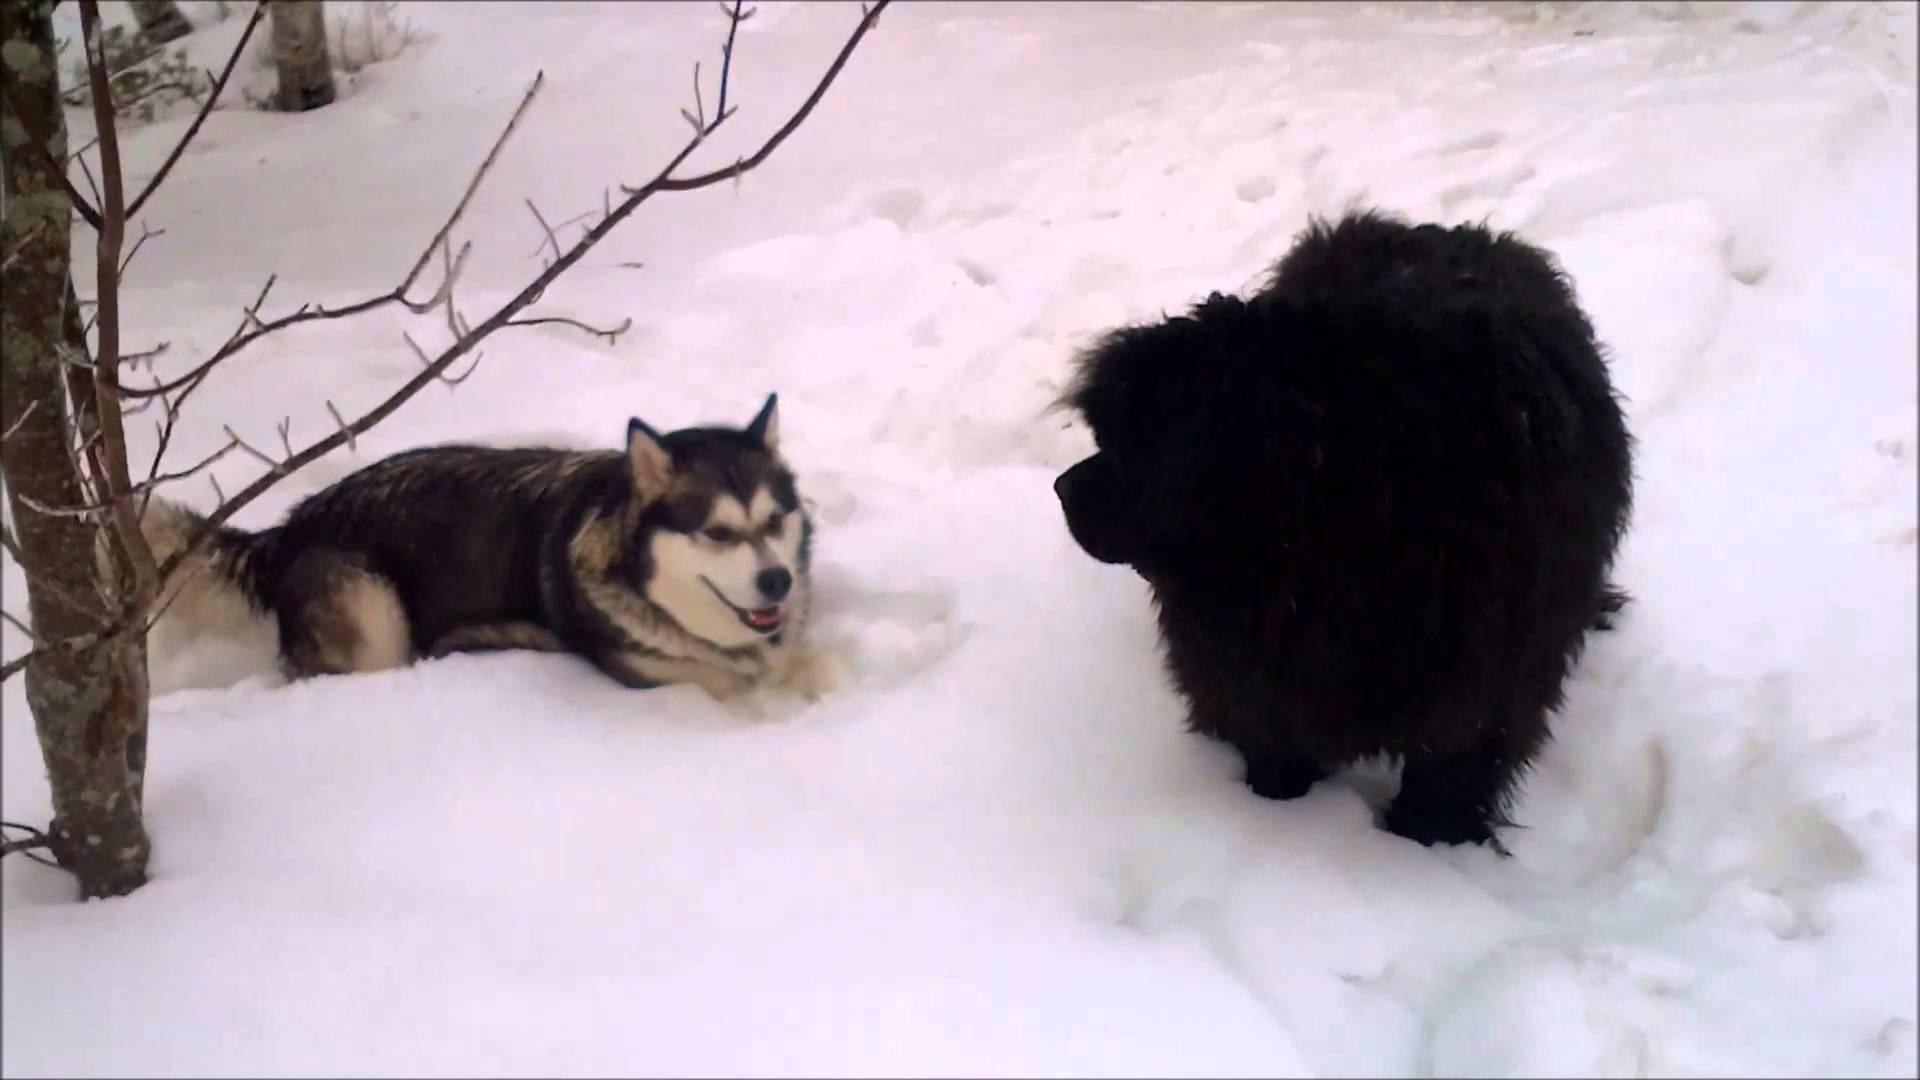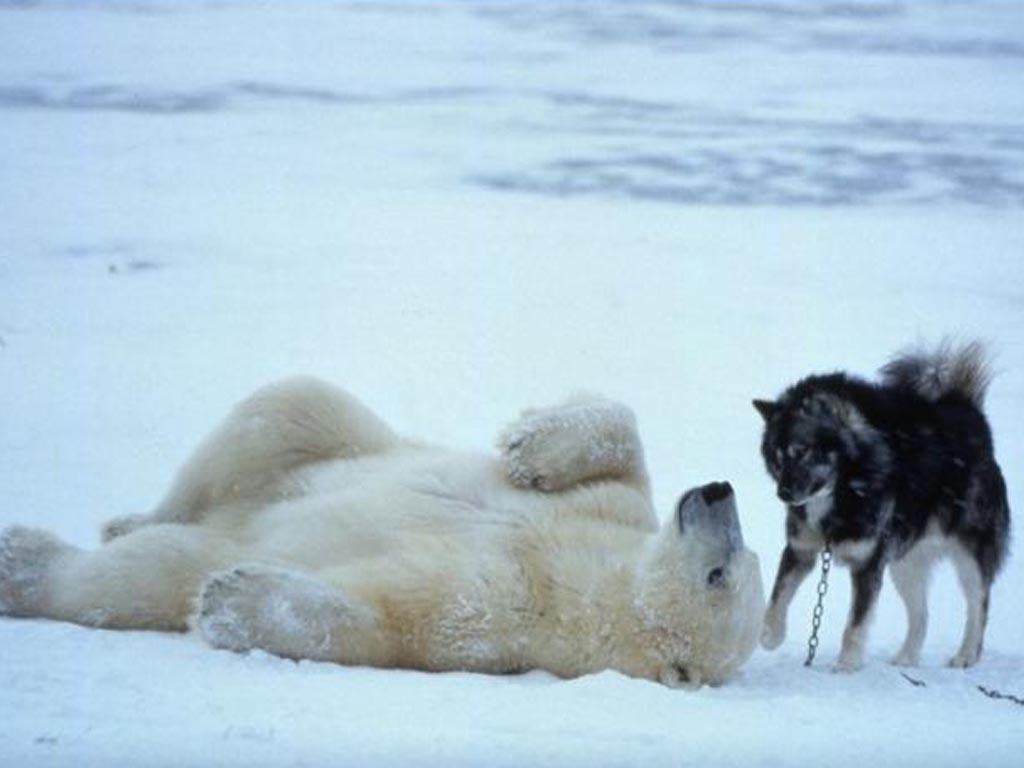The first image is the image on the left, the second image is the image on the right. Analyze the images presented: Is the assertion "At least one of the images shows a dog interacting with a mammal that is not a dog." valid? Answer yes or no. Yes. The first image is the image on the left, the second image is the image on the right. For the images shown, is this caption "There are four animals." true? Answer yes or no. Yes. 